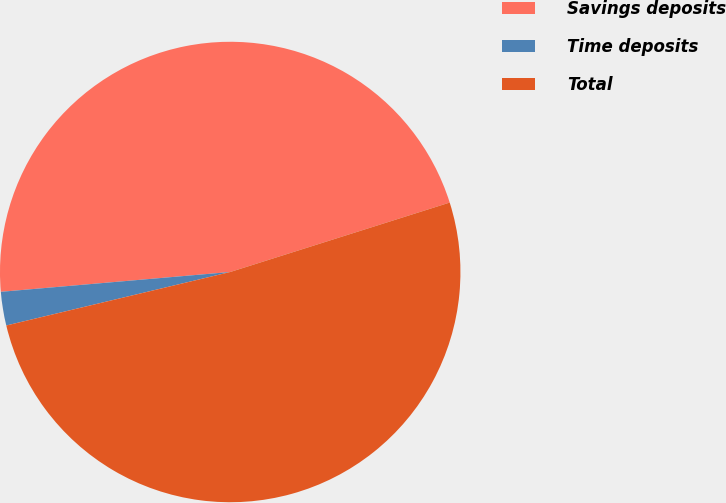Convert chart. <chart><loc_0><loc_0><loc_500><loc_500><pie_chart><fcel>Savings deposits<fcel>Time deposits<fcel>Total<nl><fcel>46.49%<fcel>2.36%<fcel>51.14%<nl></chart> 